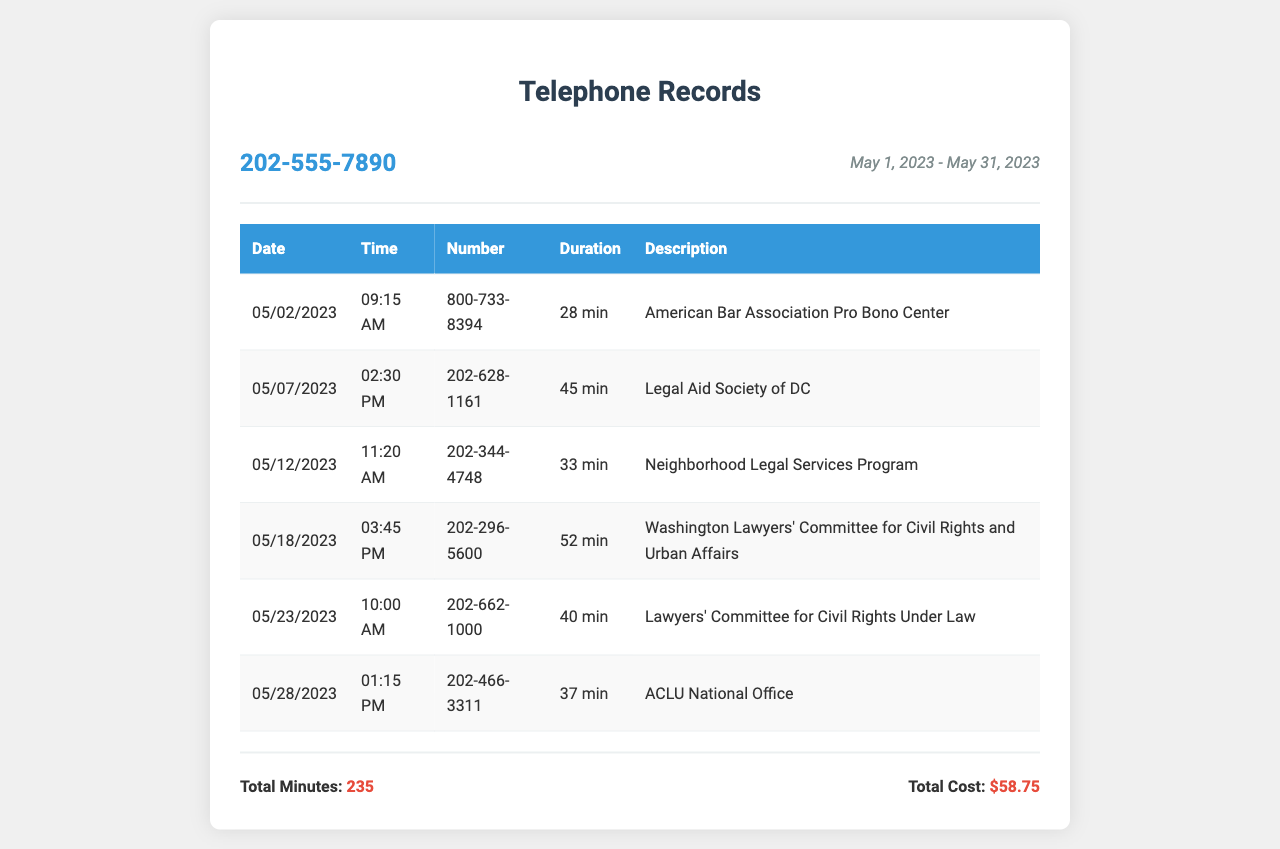what is the phone number listed in the records? The phone number shown at the top of the document is the personal phone number associated with the records.
Answer: 202-555-7890 what is the total duration of calls made? The total duration of all calls in the records is provided in the footer section of the document.
Answer: 235 how much did the calls cost in total? The total cost for all the calls made during the billing period is calculated at the bottom of the document.
Answer: $58.75 what organization was called on May 18, 2023? The entry for that date specifies the organization that was contacted, which is listed in the table.
Answer: Washington Lawyers' Committee for Civil Rights and Urban Affairs how long was the call to the ACLU National Office? The duration of the call to the ACLU National Office is included in the details of the call listed in the table.
Answer: 37 min which organization was contacted 5 days after the call to the Legal Aid Society of DC? This question requires finding the call preceding a specific organization and then identifying the following organization in the list.
Answer: Lawyers' Committee for Civil Rights Under Law how many calls were made to legal aid clinics? This counts the number of unique organizations that provide legal aid services listed in the document.
Answer: 6 which number corresponds to the American Bar Association Pro Bono Center? The table includes the specific contact number associated with this organization, which can be easily identified.
Answer: 800-733-8394 what was the date of the first recorded call? The first row of the table shows the earliest date of the recorded call made.
Answer: 05/02/2023 